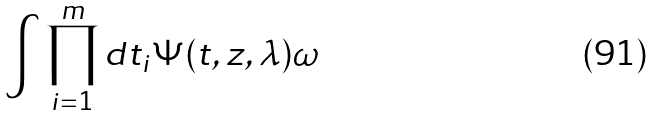Convert formula to latex. <formula><loc_0><loc_0><loc_500><loc_500>\int \prod _ { i = 1 } ^ { m } d t _ { i } \Psi ( { t , z , \lambda } ) \omega</formula> 